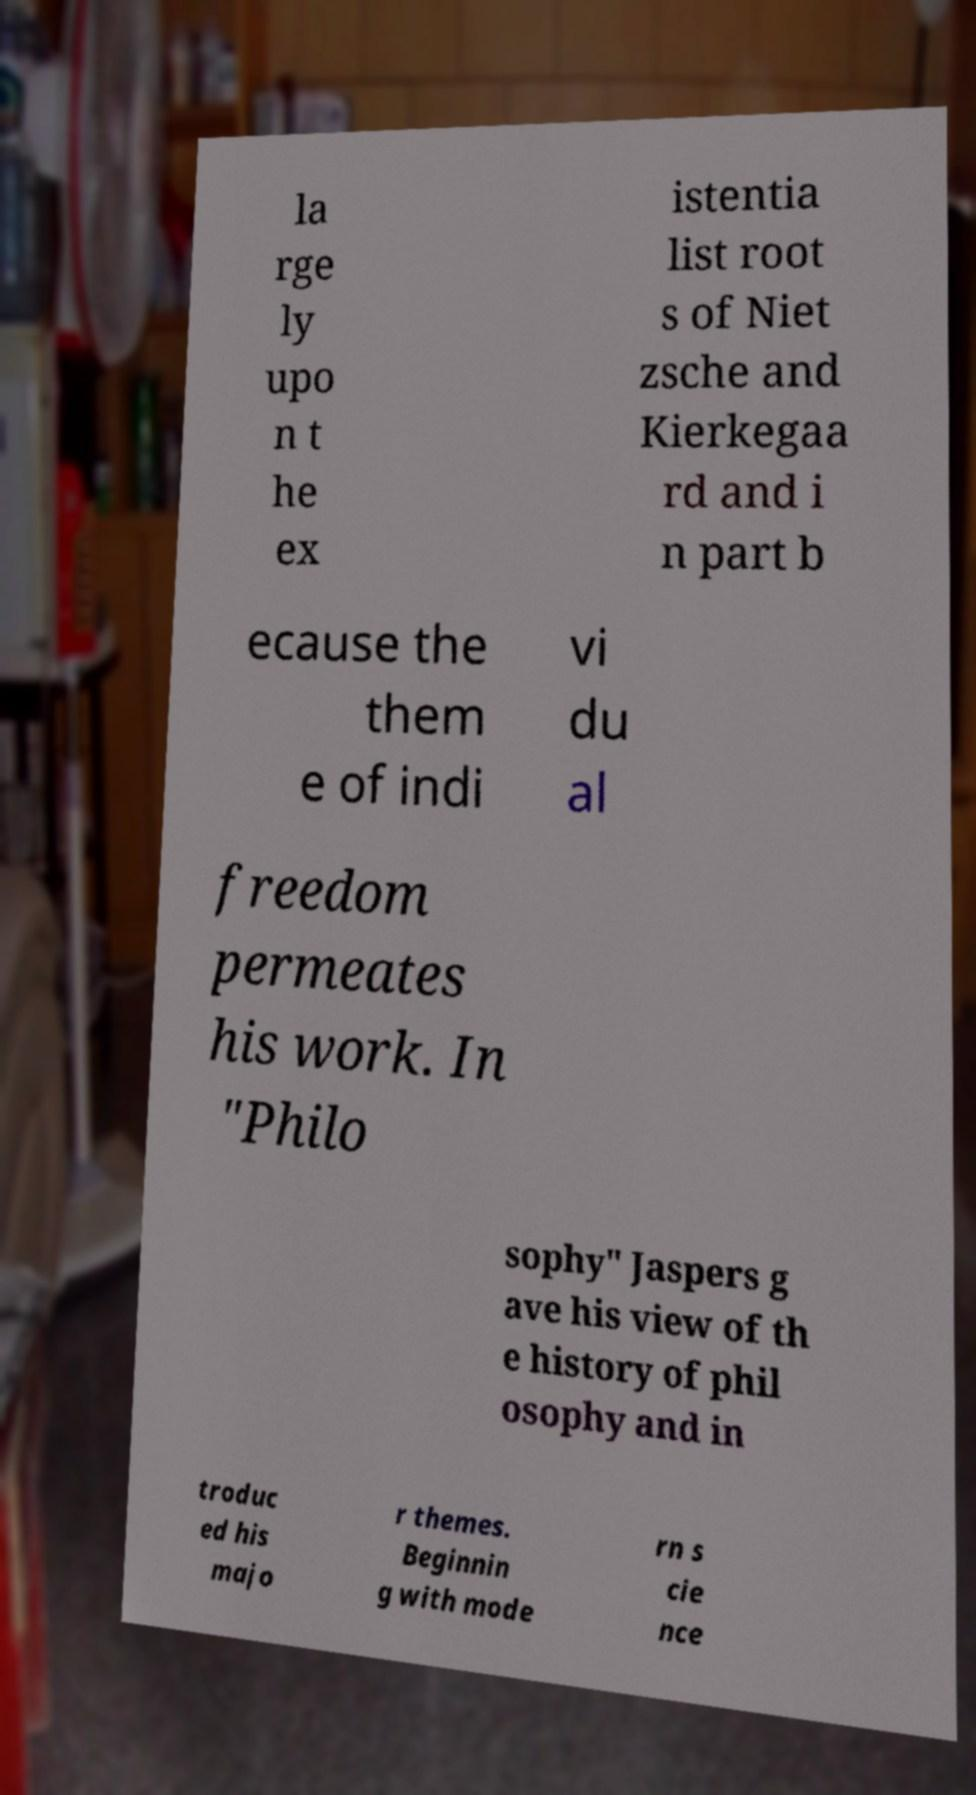For documentation purposes, I need the text within this image transcribed. Could you provide that? la rge ly upo n t he ex istentia list root s of Niet zsche and Kierkegaa rd and i n part b ecause the them e of indi vi du al freedom permeates his work. In "Philo sophy" Jaspers g ave his view of th e history of phil osophy and in troduc ed his majo r themes. Beginnin g with mode rn s cie nce 